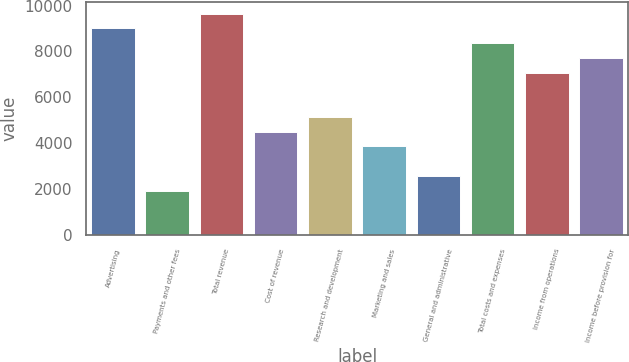<chart> <loc_0><loc_0><loc_500><loc_500><bar_chart><fcel>Advertising<fcel>Payments and other fees<fcel>Total revenue<fcel>Cost of revenue<fcel>Research and development<fcel>Marketing and sales<fcel>General and administrative<fcel>Total costs and expenses<fcel>Income from operations<fcel>Income before provision for<nl><fcel>9010.06<fcel>1931.34<fcel>9653.58<fcel>4505.42<fcel>5148.94<fcel>3861.9<fcel>2574.86<fcel>8366.54<fcel>7079.5<fcel>7723.02<nl></chart> 